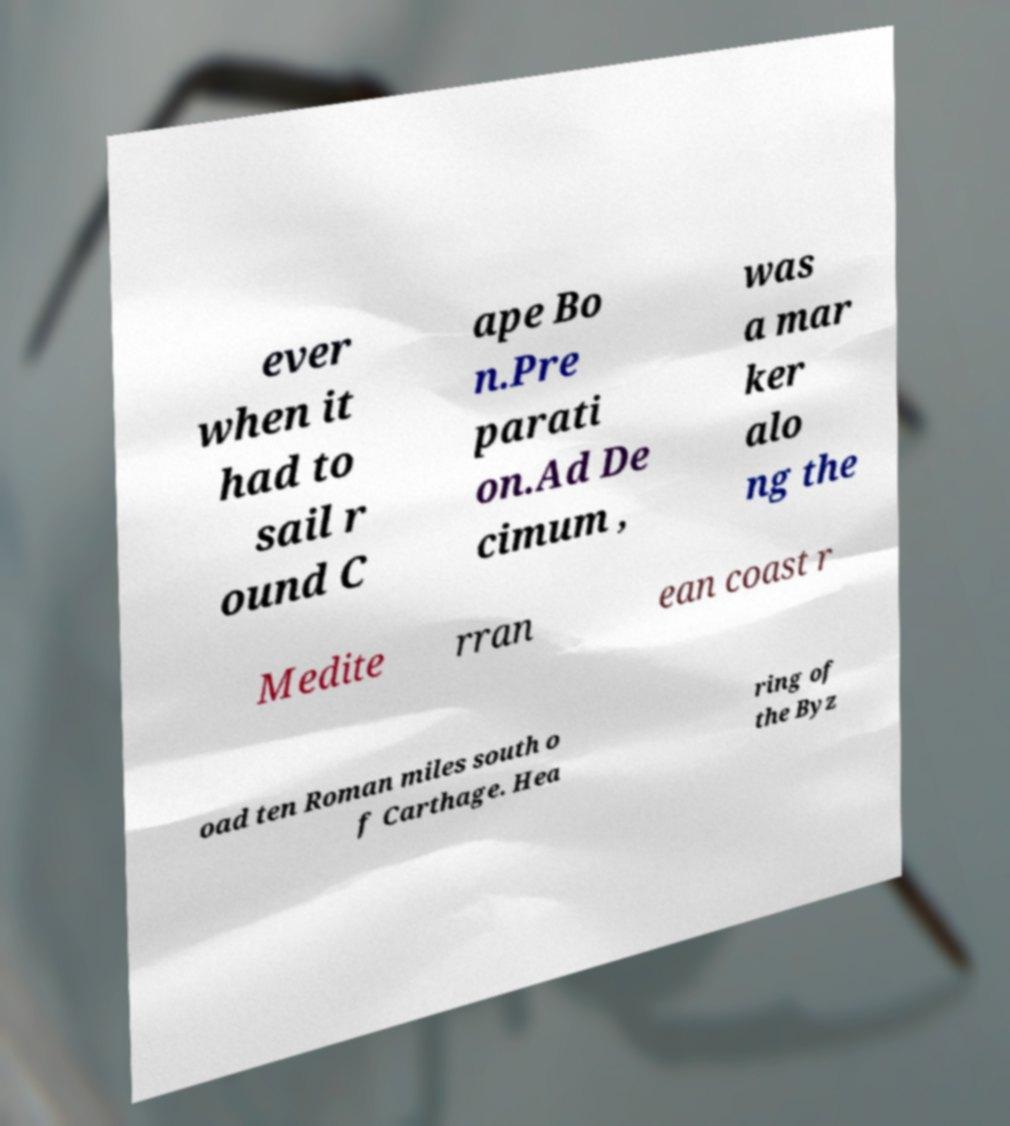Please read and relay the text visible in this image. What does it say? ever when it had to sail r ound C ape Bo n.Pre parati on.Ad De cimum , was a mar ker alo ng the Medite rran ean coast r oad ten Roman miles south o f Carthage. Hea ring of the Byz 